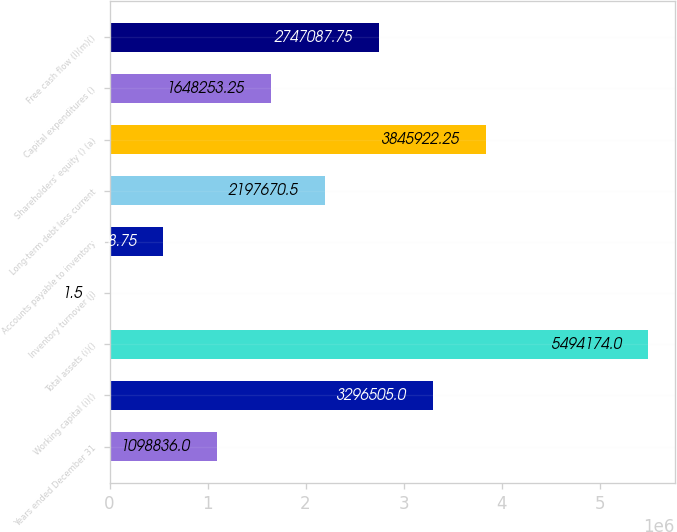Convert chart to OTSL. <chart><loc_0><loc_0><loc_500><loc_500><bar_chart><fcel>Years ended December 31<fcel>Working capital (i)()<fcel>Total assets (i)()<fcel>Inventory turnover (j)<fcel>Accounts payable to inventory<fcel>Long-term debt less current<fcel>Shareholders' equity () (a)<fcel>Capital expenditures ()<fcel>Free cash flow (l)(m)()<nl><fcel>1.09884e+06<fcel>3.2965e+06<fcel>5.49417e+06<fcel>1.5<fcel>549419<fcel>2.19767e+06<fcel>3.84592e+06<fcel>1.64825e+06<fcel>2.74709e+06<nl></chart> 